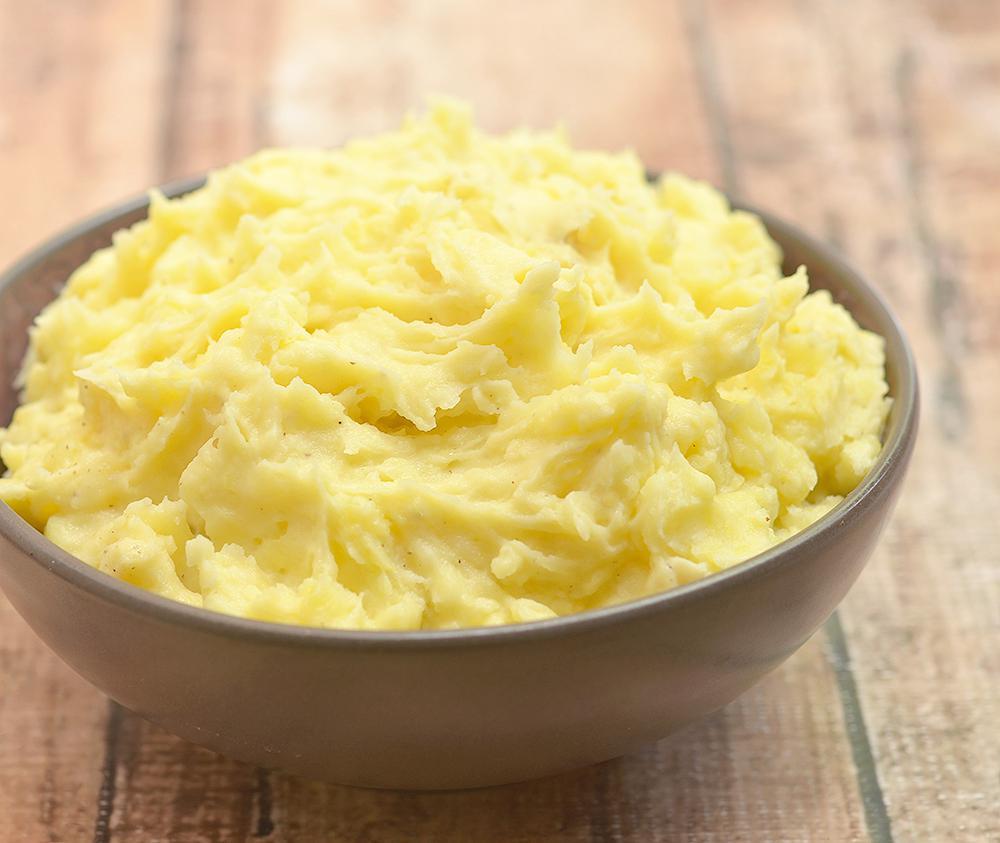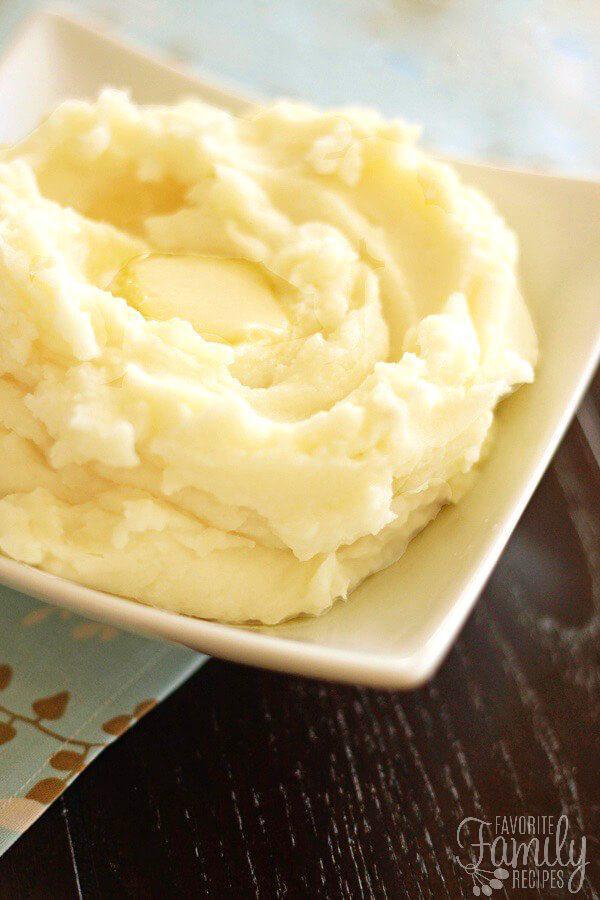The first image is the image on the left, the second image is the image on the right. Given the left and right images, does the statement "The left and right image contains the same number of round bowls holding mash potatoes." hold true? Answer yes or no. No. 